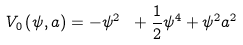Convert formula to latex. <formula><loc_0><loc_0><loc_500><loc_500>V _ { 0 } \left ( \psi , a \right ) = - \psi ^ { 2 } \ + \frac { 1 } { 2 } \psi ^ { 4 } + \psi ^ { 2 } a ^ { 2 }</formula> 